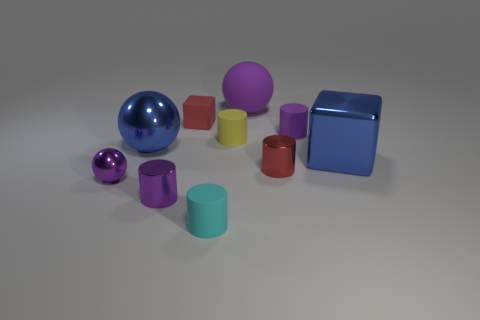Subtract all small purple shiny cylinders. How many cylinders are left? 4 Subtract all yellow cylinders. How many cylinders are left? 4 Subtract all blue cylinders. Subtract all red blocks. How many cylinders are left? 5 Subtract all blocks. How many objects are left? 8 Subtract all small red metal cylinders. Subtract all large purple matte things. How many objects are left? 8 Add 5 cyan matte cylinders. How many cyan matte cylinders are left? 6 Add 5 big blue spheres. How many big blue spheres exist? 6 Subtract 0 yellow blocks. How many objects are left? 10 